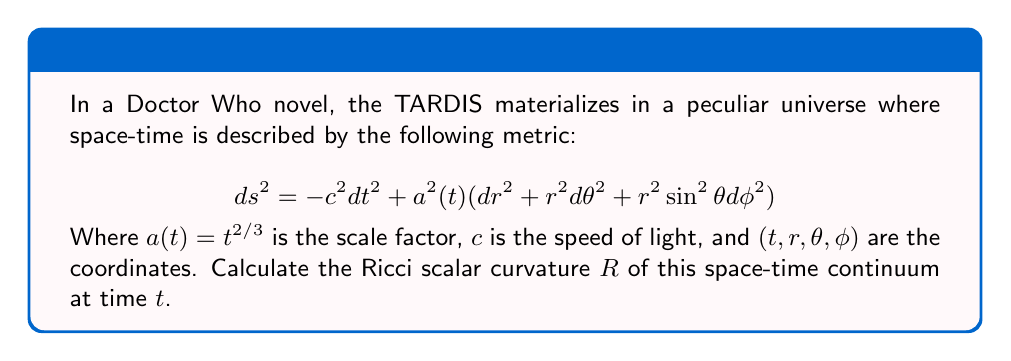Can you answer this question? To determine the Ricci scalar curvature $R$ of this space-time continuum, we need to follow these steps:

1) First, we identify this metric as a Friedmann-Lemaître-Robertson-Walker (FLRW) metric with zero spatial curvature $(k=0)$.

2) For an FLRW metric, the Ricci scalar curvature is given by:

   $$R = 6\left(\frac{\ddot{a}}{a} + \left(\frac{\dot{a}}{a}\right)^2 + \frac{k}{a^2}\right)$$

   Where $\dot{a}$ and $\ddot{a}$ are the first and second time derivatives of $a(t)$, respectively.

3) We're given that $a(t) = t^{2/3}$. Let's calculate $\dot{a}$ and $\ddot{a}$:

   $$\dot{a} = \frac{d}{dt}(t^{2/3}) = \frac{2}{3}t^{-1/3}$$

   $$\ddot{a} = \frac{d}{dt}(\frac{2}{3}t^{-1/3}) = -\frac{2}{9}t^{-4/3}$$

4) Now, let's calculate the terms inside the parentheses:

   $$\frac{\ddot{a}}{a} = \frac{-\frac{2}{9}t^{-4/3}}{t^{2/3}} = -\frac{2}{9}t^{-2}$$

   $$\left(\frac{\dot{a}}{a}\right)^2 = \left(\frac{\frac{2}{3}t^{-1/3}}{t^{2/3}}\right)^2 = \frac{4}{9}t^{-2}$$

   $$\frac{k}{a^2} = 0$$ (since $k=0$ for this metric)

5) Substituting these into our equation for $R$:

   $$R = 6\left(-\frac{2}{9}t^{-2} + \frac{4}{9}t^{-2} + 0\right)$$

6) Simplifying:

   $$R = 6\left(\frac{2}{9}t^{-2}\right) = \frac{4}{3}t^{-2}$$

This gives us the Ricci scalar curvature as a function of time $t$.
Answer: The Ricci scalar curvature of the space-time continuum is $R = \frac{4}{3}t^{-2}$. 